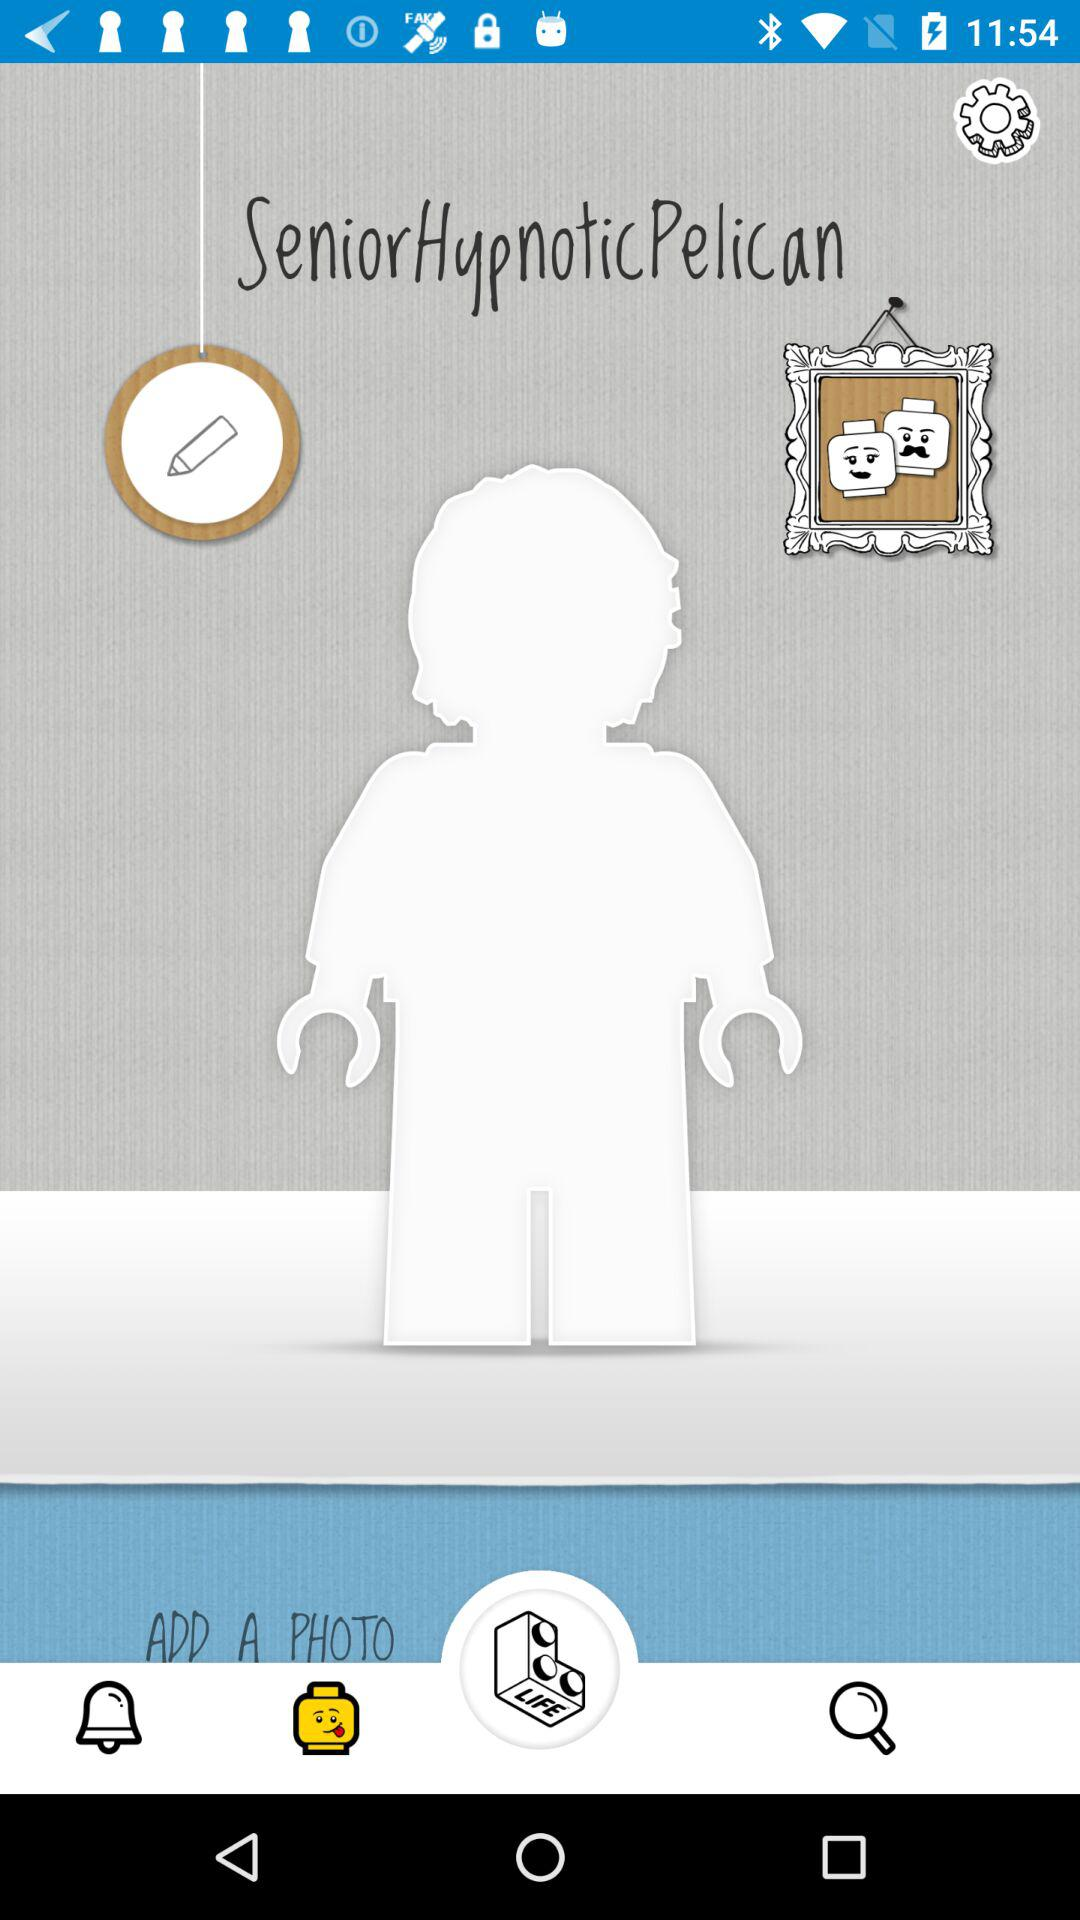What is the application name? The application name is "SeniorHypnoticPelican". 